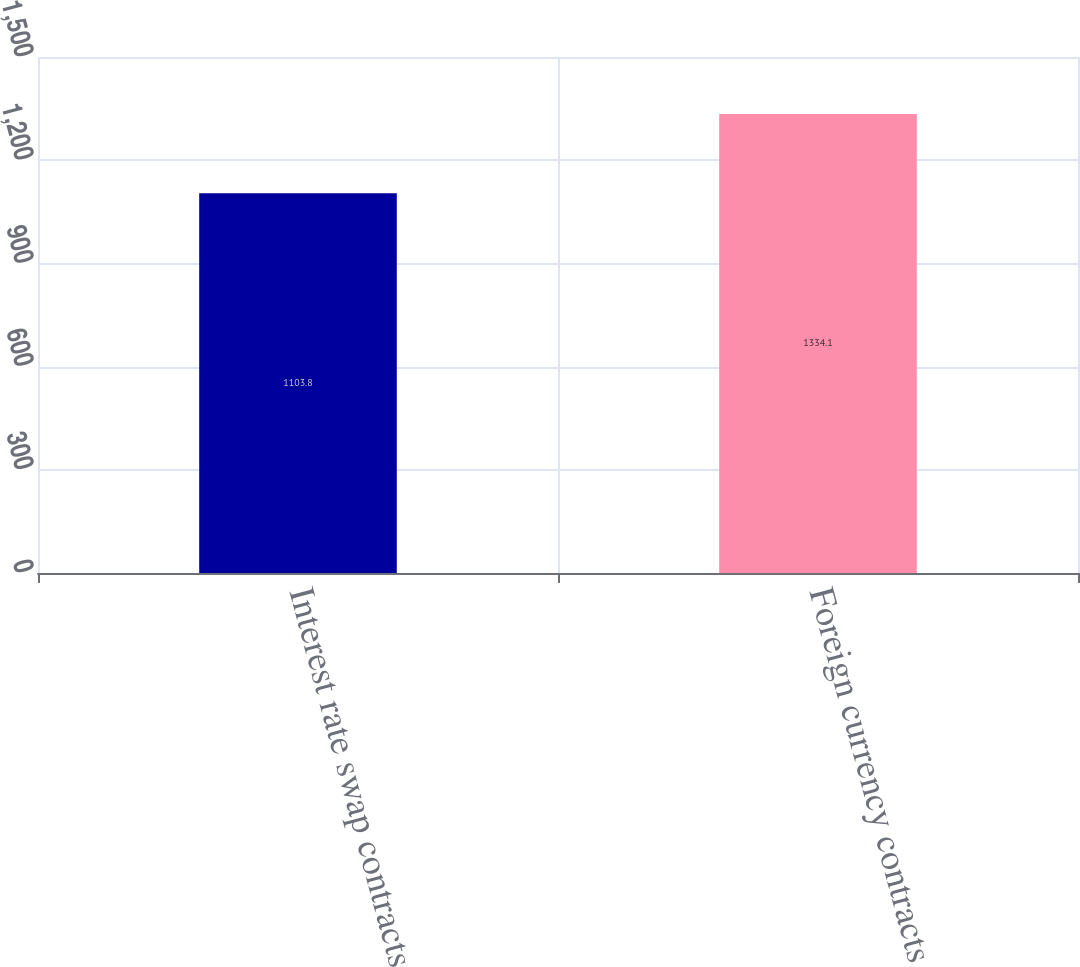<chart> <loc_0><loc_0><loc_500><loc_500><bar_chart><fcel>Interest rate swap contracts<fcel>Foreign currency contracts<nl><fcel>1103.8<fcel>1334.1<nl></chart> 